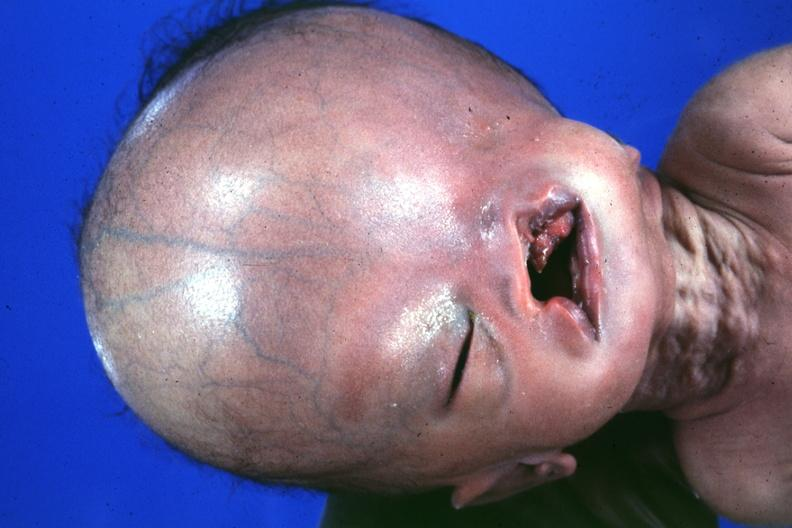does absence of palpebral fissure cleft palate see head see protocol for details?
Answer the question using a single word or phrase. Yes 